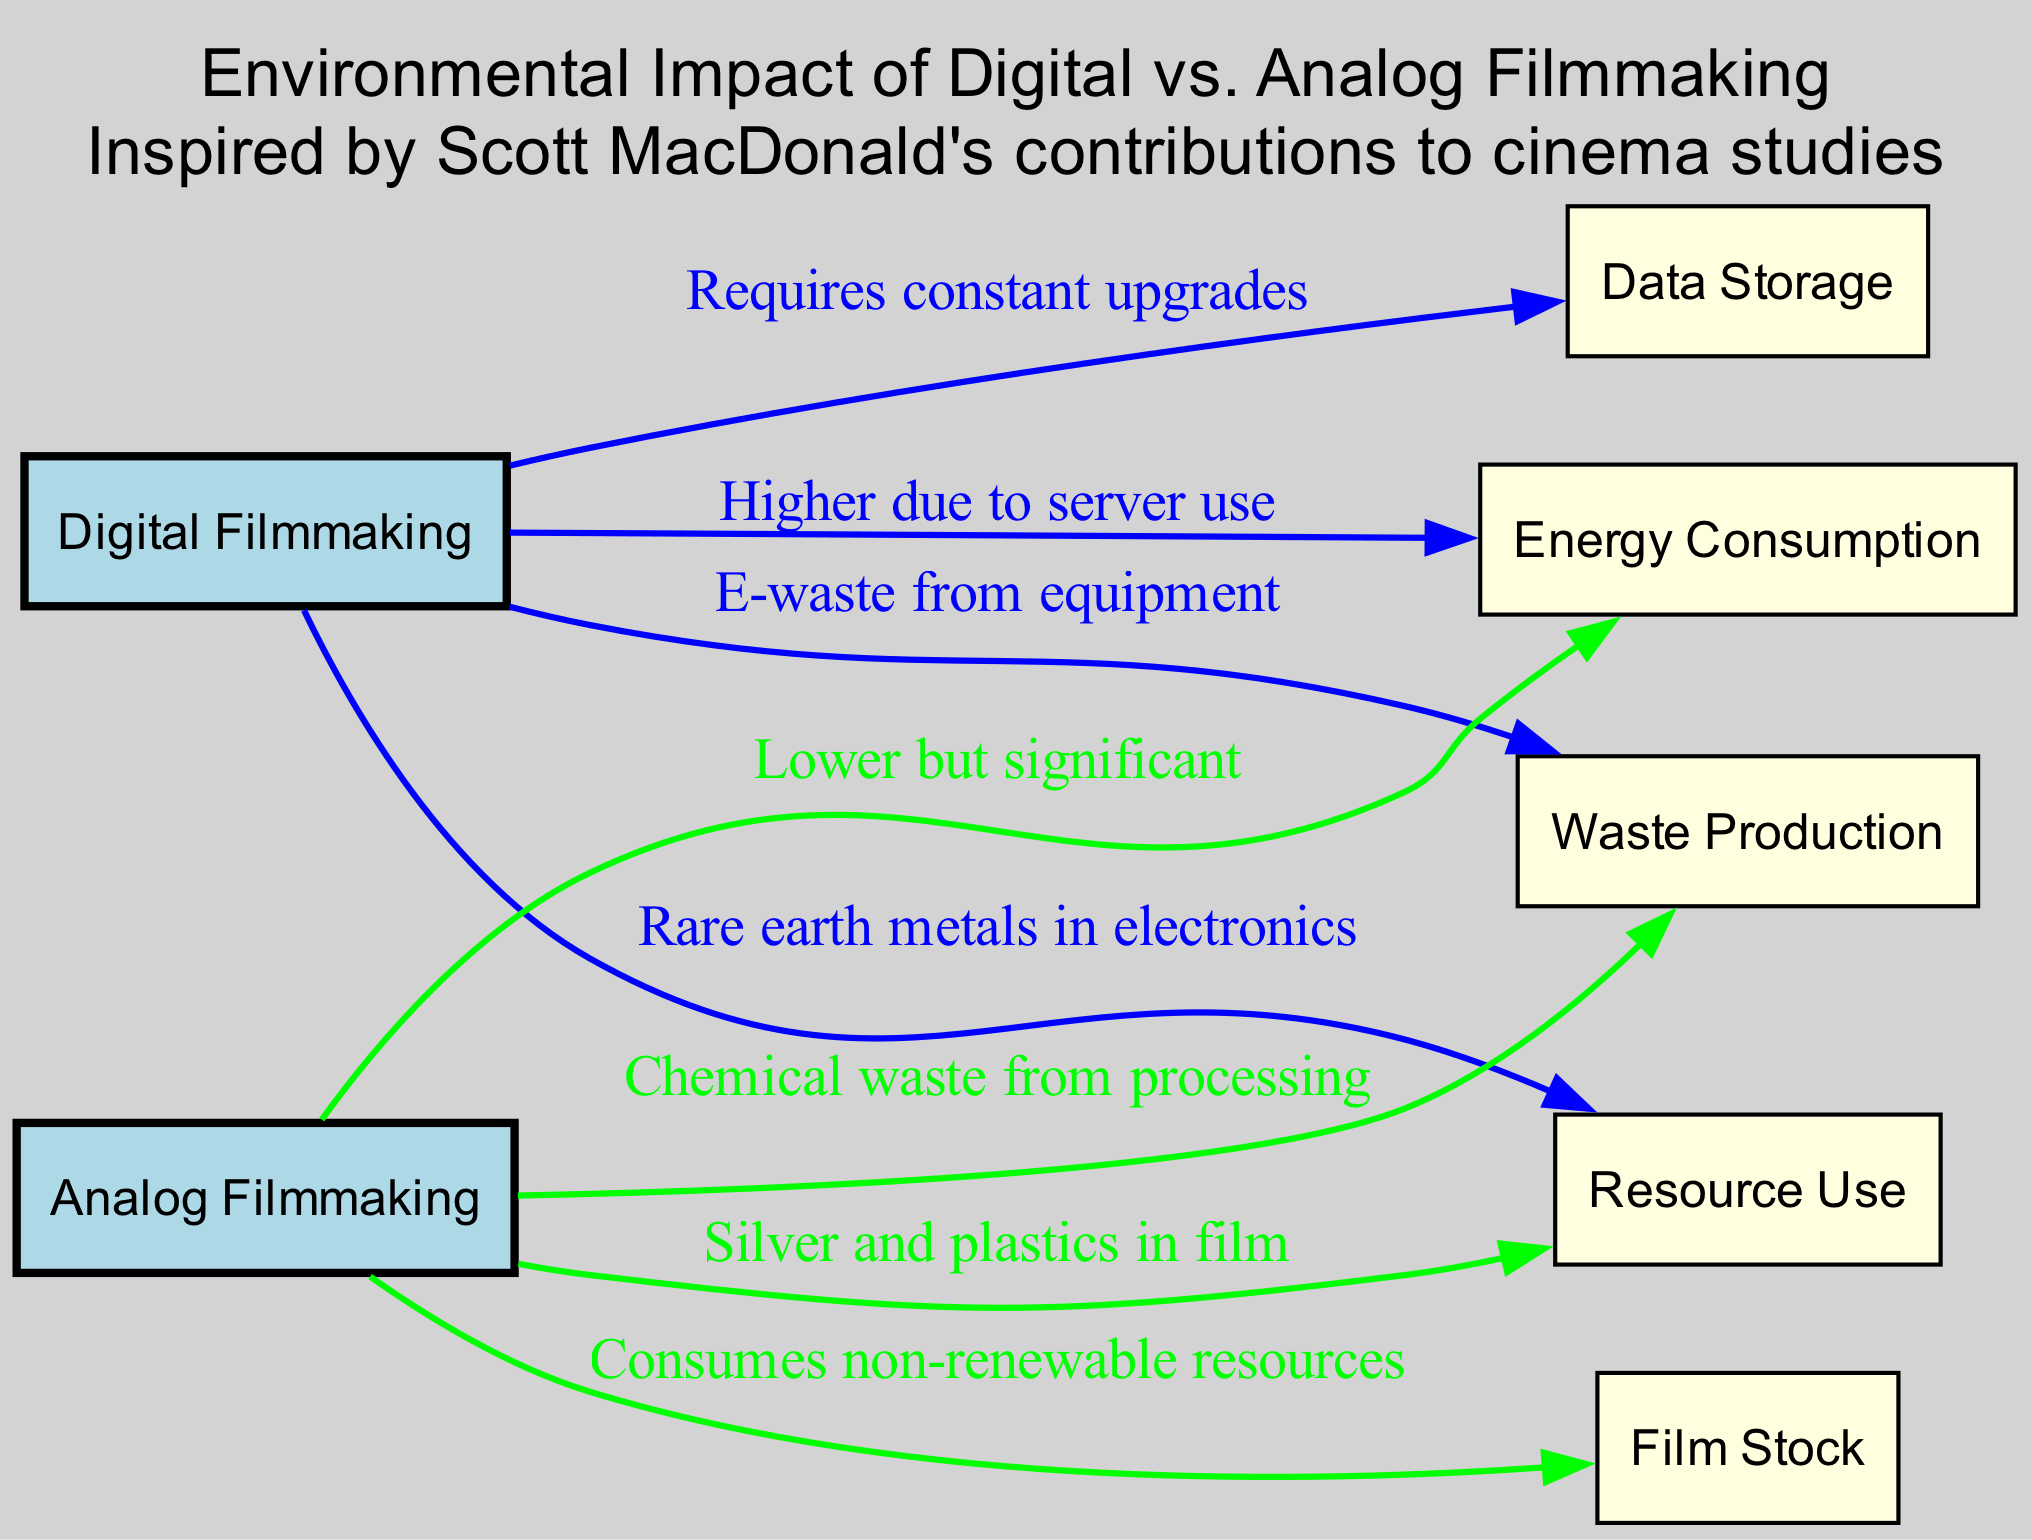What are the two types of filmmaking represented in the diagram? The diagram includes two nodes representing types of filmmaking: "Digital Filmmaking" and "Analog Filmmaking." They are explicitly identified at the top of the diagram.
Answer: Digital Filmmaking, Analog Filmmaking How many nodes are in the diagram? The diagram includes a total of 6 nodes: Digital Filmmaking, Analog Filmmaking, Energy Consumption, Waste Production, Resource Use, Data Storage, and Film Stock. Counting each one gives the total.
Answer: 8 Which type of filmmaking is associated with higher energy consumption? The edge from "Digital Filmmaking" to "Energy Consumption" states that it is "Higher due to server use." Thus, digital filmmaking has the higher energy consumption.
Answer: Digital Filmmaking What type of waste is produced by digital filmmaking? The edge connecting "Digital Filmmaking" to "Waste Production" indicates that "E-waste from equipment" is the type of waste produced, providing a direct link.
Answer: E-waste from equipment What are the resources used in analog filmmaking? The edge from "Analog Filmmaking" connects to "Resource Use," indicating "Silver and plastics in film" as the materials. This can be identified by looking directly at the edge description.
Answer: Silver and plastics in film Which filmmaking method requires constant upgrades? The edge labeled as "Requires constant upgrades" points from "Digital Filmmaking" to "Data Storage," showing that only digital filmmaking requires these regular updates.
Answer: Digital Filmmaking How does analog filmmaking impact waste production? The edge from "Analog Filmmaking" to "Waste Production" specifies that it generates "Chemical waste from processing," clearly describing the impact of this method on waste.
Answer: Chemical waste from processing Which type of filmmaking consumes non-renewable resources? The connection from "Analog Filmmaking" to "Film Stock" notes that it "Consumes non-renewable resources," indicating that this is the focus for non-renewable use.
Answer: Analog Filmmaking 